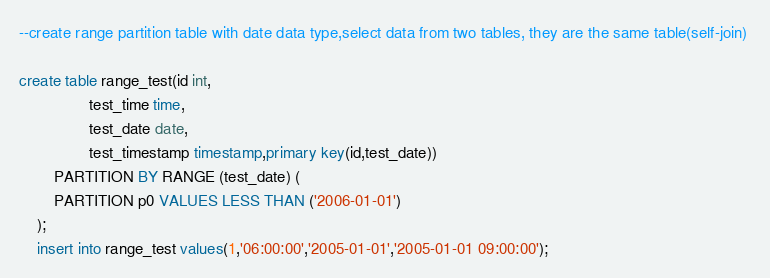Convert code to text. <code><loc_0><loc_0><loc_500><loc_500><_SQL_>--create range partition table with date data type,select data from two tables, they are the same table(self-join) 

create table range_test(id int,	
				test_time time,
				test_date date,
				test_timestamp timestamp,primary key(id,test_date))
		PARTITION BY RANGE (test_date) (
		PARTITION p0 VALUES LESS THAN ('2006-01-01')
	);
	insert into range_test values(1,'06:00:00','2005-01-01','2005-01-01 09:00:00');</code> 